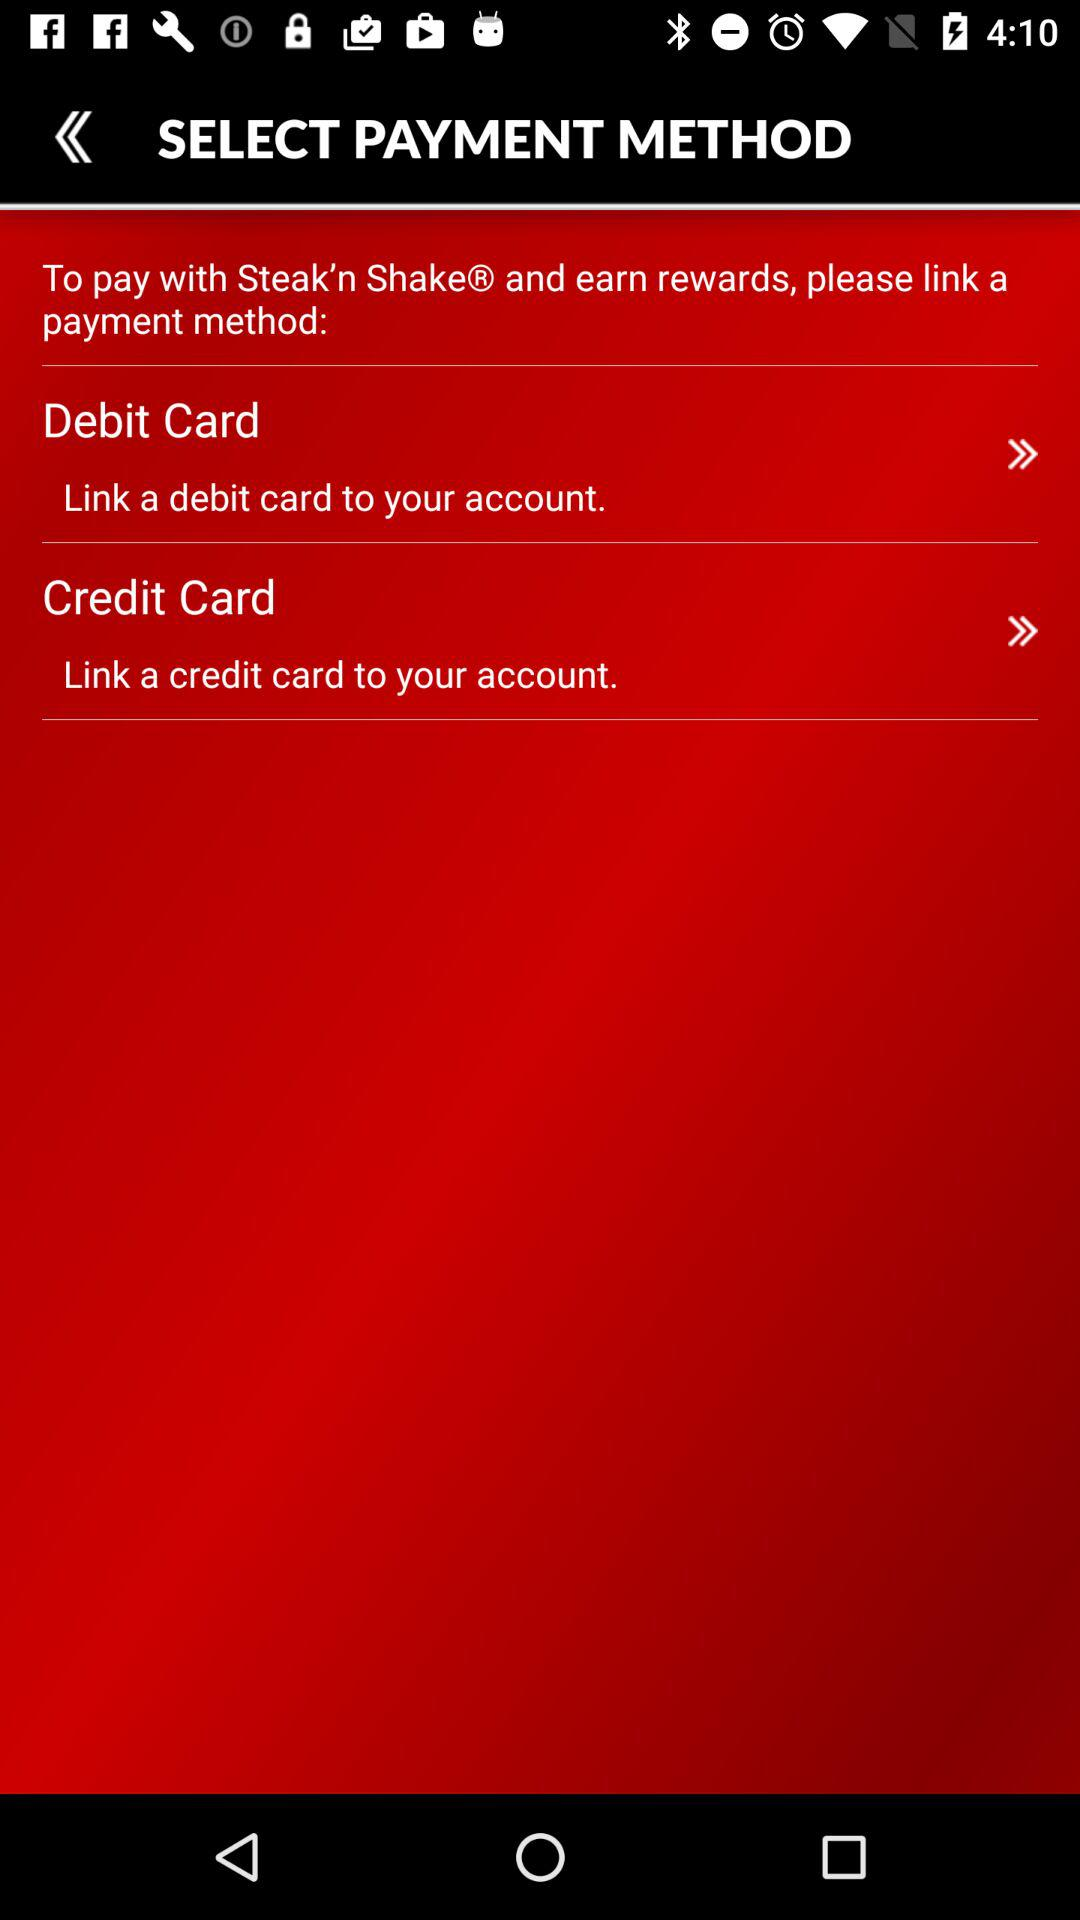How many payment methods can I choose from?
Answer the question using a single word or phrase. 2 